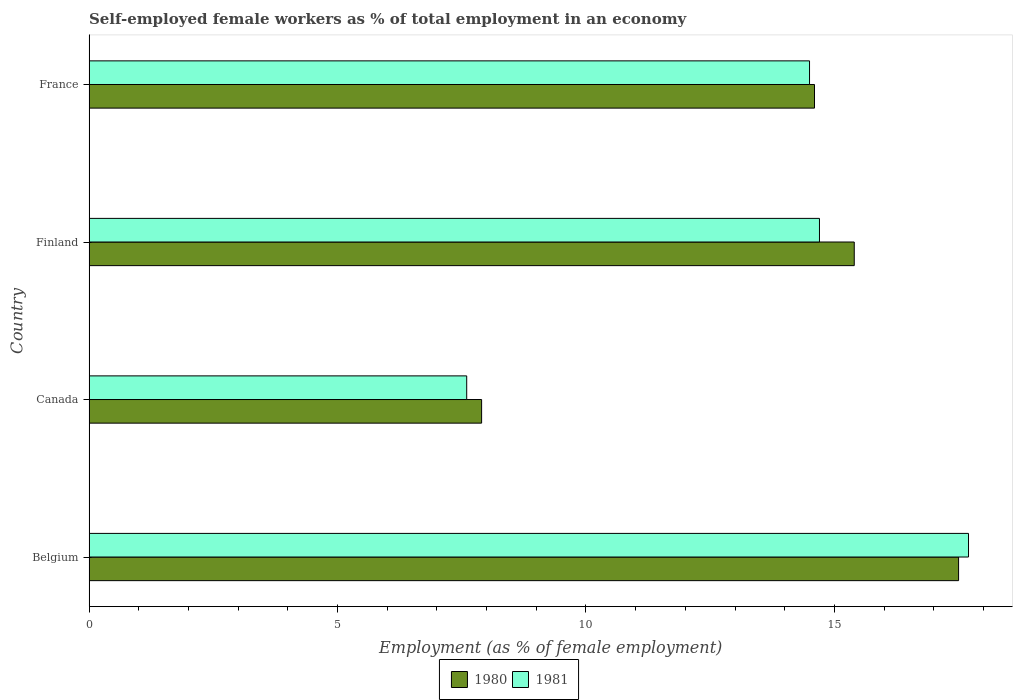How many groups of bars are there?
Your answer should be very brief. 4. Are the number of bars per tick equal to the number of legend labels?
Offer a terse response. Yes. Are the number of bars on each tick of the Y-axis equal?
Your answer should be very brief. Yes. How many bars are there on the 4th tick from the bottom?
Keep it short and to the point. 2. In how many cases, is the number of bars for a given country not equal to the number of legend labels?
Your answer should be compact. 0. What is the percentage of self-employed female workers in 1981 in Belgium?
Your answer should be very brief. 17.7. Across all countries, what is the maximum percentage of self-employed female workers in 1981?
Your response must be concise. 17.7. Across all countries, what is the minimum percentage of self-employed female workers in 1980?
Offer a very short reply. 7.9. In which country was the percentage of self-employed female workers in 1981 maximum?
Provide a short and direct response. Belgium. In which country was the percentage of self-employed female workers in 1981 minimum?
Make the answer very short. Canada. What is the total percentage of self-employed female workers in 1980 in the graph?
Provide a succinct answer. 55.4. What is the difference between the percentage of self-employed female workers in 1981 in Finland and that in France?
Provide a succinct answer. 0.2. What is the average percentage of self-employed female workers in 1981 per country?
Provide a succinct answer. 13.63. What is the difference between the percentage of self-employed female workers in 1980 and percentage of self-employed female workers in 1981 in Belgium?
Provide a short and direct response. -0.2. In how many countries, is the percentage of self-employed female workers in 1980 greater than 9 %?
Ensure brevity in your answer.  3. What is the ratio of the percentage of self-employed female workers in 1980 in Belgium to that in Canada?
Provide a short and direct response. 2.22. Is the percentage of self-employed female workers in 1981 in Canada less than that in France?
Offer a very short reply. Yes. What is the difference between the highest and the second highest percentage of self-employed female workers in 1980?
Offer a very short reply. 2.1. What is the difference between the highest and the lowest percentage of self-employed female workers in 1981?
Provide a succinct answer. 10.1. What does the 2nd bar from the top in Canada represents?
Your answer should be compact. 1980. What does the 2nd bar from the bottom in France represents?
Give a very brief answer. 1981. How many countries are there in the graph?
Offer a very short reply. 4. What is the difference between two consecutive major ticks on the X-axis?
Provide a short and direct response. 5. Are the values on the major ticks of X-axis written in scientific E-notation?
Offer a very short reply. No. Does the graph contain any zero values?
Make the answer very short. No. How are the legend labels stacked?
Offer a terse response. Horizontal. What is the title of the graph?
Your answer should be compact. Self-employed female workers as % of total employment in an economy. What is the label or title of the X-axis?
Your response must be concise. Employment (as % of female employment). What is the Employment (as % of female employment) in 1980 in Belgium?
Provide a short and direct response. 17.5. What is the Employment (as % of female employment) of 1981 in Belgium?
Keep it short and to the point. 17.7. What is the Employment (as % of female employment) in 1980 in Canada?
Your answer should be very brief. 7.9. What is the Employment (as % of female employment) of 1981 in Canada?
Offer a very short reply. 7.6. What is the Employment (as % of female employment) of 1980 in Finland?
Your answer should be very brief. 15.4. What is the Employment (as % of female employment) in 1981 in Finland?
Your response must be concise. 14.7. What is the Employment (as % of female employment) in 1980 in France?
Offer a very short reply. 14.6. Across all countries, what is the maximum Employment (as % of female employment) of 1980?
Provide a short and direct response. 17.5. Across all countries, what is the maximum Employment (as % of female employment) of 1981?
Offer a terse response. 17.7. Across all countries, what is the minimum Employment (as % of female employment) in 1980?
Make the answer very short. 7.9. Across all countries, what is the minimum Employment (as % of female employment) of 1981?
Give a very brief answer. 7.6. What is the total Employment (as % of female employment) of 1980 in the graph?
Your answer should be very brief. 55.4. What is the total Employment (as % of female employment) in 1981 in the graph?
Keep it short and to the point. 54.5. What is the difference between the Employment (as % of female employment) of 1980 in Belgium and that in Canada?
Your answer should be compact. 9.6. What is the difference between the Employment (as % of female employment) in 1980 in Belgium and that in France?
Give a very brief answer. 2.9. What is the difference between the Employment (as % of female employment) in 1981 in Canada and that in Finland?
Give a very brief answer. -7.1. What is the difference between the Employment (as % of female employment) of 1980 in Canada and that in France?
Your response must be concise. -6.7. What is the difference between the Employment (as % of female employment) in 1981 in Canada and that in France?
Your answer should be compact. -6.9. What is the difference between the Employment (as % of female employment) in 1980 in Finland and that in France?
Offer a very short reply. 0.8. What is the difference between the Employment (as % of female employment) of 1980 in Belgium and the Employment (as % of female employment) of 1981 in Canada?
Your response must be concise. 9.9. What is the difference between the Employment (as % of female employment) of 1980 in Belgium and the Employment (as % of female employment) of 1981 in France?
Offer a very short reply. 3. What is the difference between the Employment (as % of female employment) of 1980 in Canada and the Employment (as % of female employment) of 1981 in France?
Make the answer very short. -6.6. What is the difference between the Employment (as % of female employment) in 1980 in Finland and the Employment (as % of female employment) in 1981 in France?
Your response must be concise. 0.9. What is the average Employment (as % of female employment) of 1980 per country?
Make the answer very short. 13.85. What is the average Employment (as % of female employment) in 1981 per country?
Ensure brevity in your answer.  13.62. What is the difference between the Employment (as % of female employment) in 1980 and Employment (as % of female employment) in 1981 in Canada?
Ensure brevity in your answer.  0.3. What is the difference between the Employment (as % of female employment) of 1980 and Employment (as % of female employment) of 1981 in France?
Keep it short and to the point. 0.1. What is the ratio of the Employment (as % of female employment) of 1980 in Belgium to that in Canada?
Give a very brief answer. 2.22. What is the ratio of the Employment (as % of female employment) in 1981 in Belgium to that in Canada?
Give a very brief answer. 2.33. What is the ratio of the Employment (as % of female employment) in 1980 in Belgium to that in Finland?
Your response must be concise. 1.14. What is the ratio of the Employment (as % of female employment) in 1981 in Belgium to that in Finland?
Keep it short and to the point. 1.2. What is the ratio of the Employment (as % of female employment) in 1980 in Belgium to that in France?
Provide a succinct answer. 1.2. What is the ratio of the Employment (as % of female employment) of 1981 in Belgium to that in France?
Offer a terse response. 1.22. What is the ratio of the Employment (as % of female employment) of 1980 in Canada to that in Finland?
Offer a terse response. 0.51. What is the ratio of the Employment (as % of female employment) of 1981 in Canada to that in Finland?
Ensure brevity in your answer.  0.52. What is the ratio of the Employment (as % of female employment) in 1980 in Canada to that in France?
Provide a short and direct response. 0.54. What is the ratio of the Employment (as % of female employment) of 1981 in Canada to that in France?
Your response must be concise. 0.52. What is the ratio of the Employment (as % of female employment) of 1980 in Finland to that in France?
Offer a very short reply. 1.05. What is the ratio of the Employment (as % of female employment) of 1981 in Finland to that in France?
Your response must be concise. 1.01. What is the difference between the highest and the second highest Employment (as % of female employment) of 1980?
Ensure brevity in your answer.  2.1. What is the difference between the highest and the second highest Employment (as % of female employment) in 1981?
Provide a short and direct response. 3. What is the difference between the highest and the lowest Employment (as % of female employment) of 1980?
Your answer should be very brief. 9.6. 